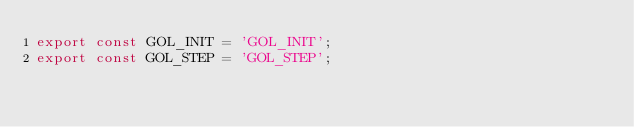Convert code to text. <code><loc_0><loc_0><loc_500><loc_500><_JavaScript_>export const GOL_INIT = 'GOL_INIT';
export const GOL_STEP = 'GOL_STEP';
</code> 